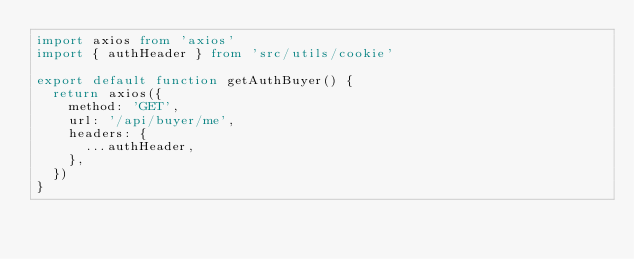Convert code to text. <code><loc_0><loc_0><loc_500><loc_500><_TypeScript_>import axios from 'axios'
import { authHeader } from 'src/utils/cookie'

export default function getAuthBuyer() {
  return axios({
    method: 'GET',
    url: '/api/buyer/me',
    headers: {
      ...authHeader,
    },
  })
}
</code> 